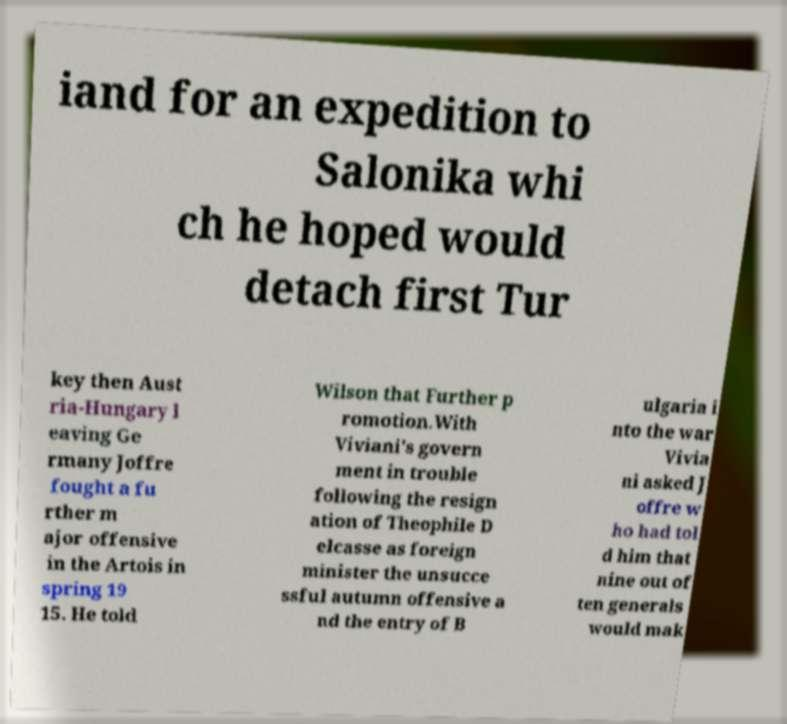Please identify and transcribe the text found in this image. iand for an expedition to Salonika whi ch he hoped would detach first Tur key then Aust ria-Hungary l eaving Ge rmany Joffre fought a fu rther m ajor offensive in the Artois in spring 19 15. He told Wilson that Further p romotion.With Viviani's govern ment in trouble following the resign ation of Theophile D elcasse as foreign minister the unsucce ssful autumn offensive a nd the entry of B ulgaria i nto the war Vivia ni asked J offre w ho had tol d him that nine out of ten generals would mak 